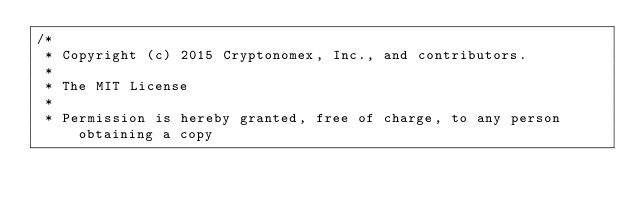<code> <loc_0><loc_0><loc_500><loc_500><_C++_>/*
 * Copyright (c) 2015 Cryptonomex, Inc., and contributors.
 *
 * The MIT License
 *
 * Permission is hereby granted, free of charge, to any person obtaining a copy</code> 